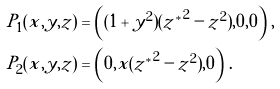<formula> <loc_0><loc_0><loc_500><loc_500>P _ { 1 } ( x , y , z ) & = \left ( ( 1 + y ^ { 2 } ) ( { z ^ { * } } ^ { 2 } - z ^ { 2 } ) , 0 , 0 \right ) \, , \\ P _ { 2 } ( x , y , z ) & = \left ( 0 , x ( { z ^ { * } } ^ { 2 } - z ^ { 2 } ) , 0 \right ) \, . \\</formula> 